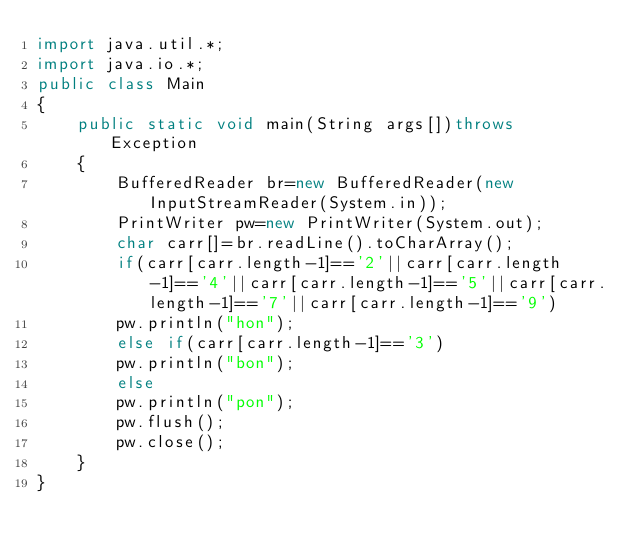<code> <loc_0><loc_0><loc_500><loc_500><_Java_>import java.util.*;
import java.io.*;
public class Main
{
    public static void main(String args[])throws Exception
    {
        BufferedReader br=new BufferedReader(new InputStreamReader(System.in));
        PrintWriter pw=new PrintWriter(System.out);
        char carr[]=br.readLine().toCharArray();
        if(carr[carr.length-1]=='2'||carr[carr.length-1]=='4'||carr[carr.length-1]=='5'||carr[carr.length-1]=='7'||carr[carr.length-1]=='9')
        pw.println("hon");
        else if(carr[carr.length-1]=='3')
        pw.println("bon");
        else
        pw.println("pon");
        pw.flush();
        pw.close();
    }
}</code> 